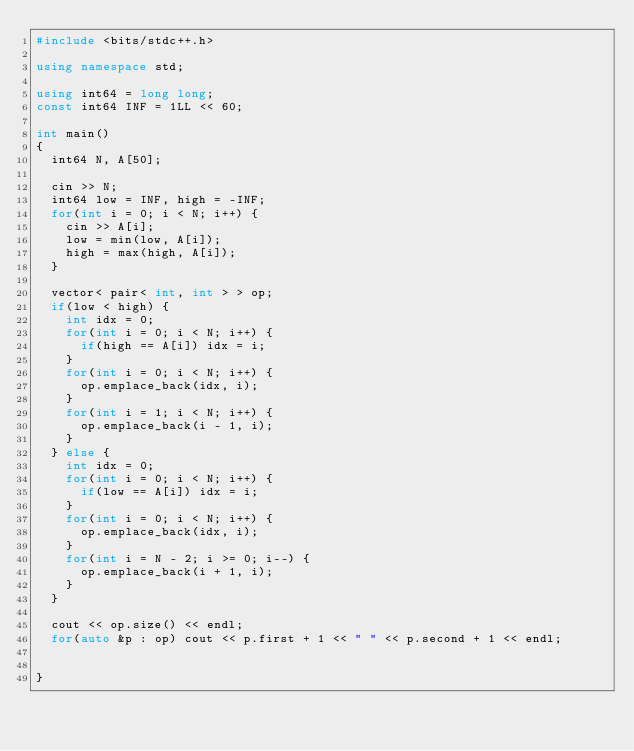Convert code to text. <code><loc_0><loc_0><loc_500><loc_500><_C++_>#include <bits/stdc++.h>

using namespace std;

using int64 = long long;
const int64 INF = 1LL << 60;

int main()
{
  int64 N, A[50];

  cin >> N;
  int64 low = INF, high = -INF;
  for(int i = 0; i < N; i++) {
    cin >> A[i];
    low = min(low, A[i]);
    high = max(high, A[i]);
  }

  vector< pair< int, int > > op;
  if(low < high) {
    int idx = 0;
    for(int i = 0; i < N; i++) {
      if(high == A[i]) idx = i;
    }
    for(int i = 0; i < N; i++) {
      op.emplace_back(idx, i);
    }
    for(int i = 1; i < N; i++) {
      op.emplace_back(i - 1, i);
    }
  } else {
    int idx = 0;
    for(int i = 0; i < N; i++) {
      if(low == A[i]) idx = i;
    }
    for(int i = 0; i < N; i++) {
      op.emplace_back(idx, i);
    }
    for(int i = N - 2; i >= 0; i--) {
      op.emplace_back(i + 1, i);
    }
  }

  cout << op.size() << endl;
  for(auto &p : op) cout << p.first + 1 << " " << p.second + 1 << endl;


}</code> 